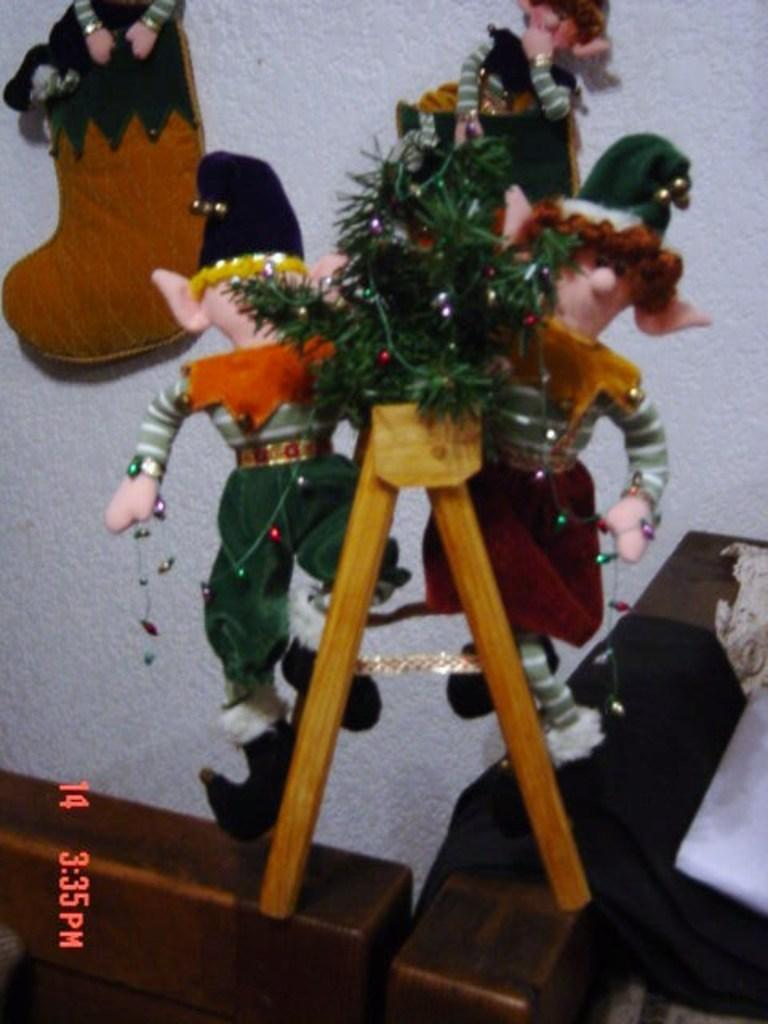What type of objects are present in the image? There are dolls in the image. Can you describe the overall theme or appearance of the image? The image resembles Christmas decoration. How many channels are available for the dolls to watch in the image? There are no channels or televisions present in the image, as it features dolls and resembles Christmas decoration. 